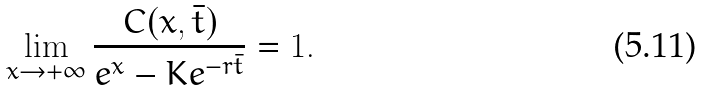<formula> <loc_0><loc_0><loc_500><loc_500>\lim _ { x \rightarrow + \infty } \frac { C ( x , \bar { t } ) } { e ^ { x } - K e ^ { - r \bar { t } } } = 1 .</formula> 